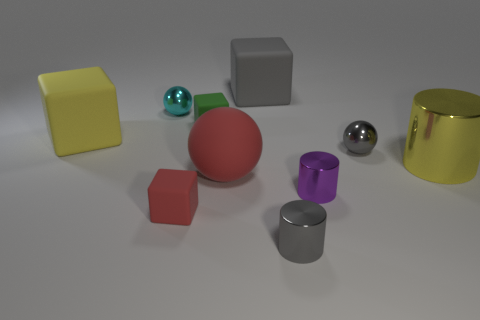There is a metal ball behind the big cube that is on the left side of the big cube to the right of the cyan shiny ball; what size is it?
Offer a terse response. Small. Is the size of the cyan thing the same as the matte ball?
Your answer should be compact. No. How many objects are either red matte objects or tiny cylinders?
Provide a short and direct response. 4. There is a gray rubber block that is on the right side of the metallic ball that is behind the small green rubber thing; how big is it?
Offer a terse response. Large. The green rubber object is what size?
Provide a succinct answer. Small. There is a shiny object that is to the left of the purple metal cylinder and in front of the large yellow cylinder; what is its shape?
Provide a short and direct response. Cylinder. There is another tiny object that is the same shape as the small green matte thing; what is its color?
Provide a succinct answer. Red. How many objects are large rubber objects that are to the left of the gray rubber cube or small shiny things that are on the left side of the small green block?
Your answer should be very brief. 3. The large red object has what shape?
Your answer should be very brief. Sphere. What is the shape of the matte thing that is the same color as the big metallic thing?
Your answer should be compact. Cube. 